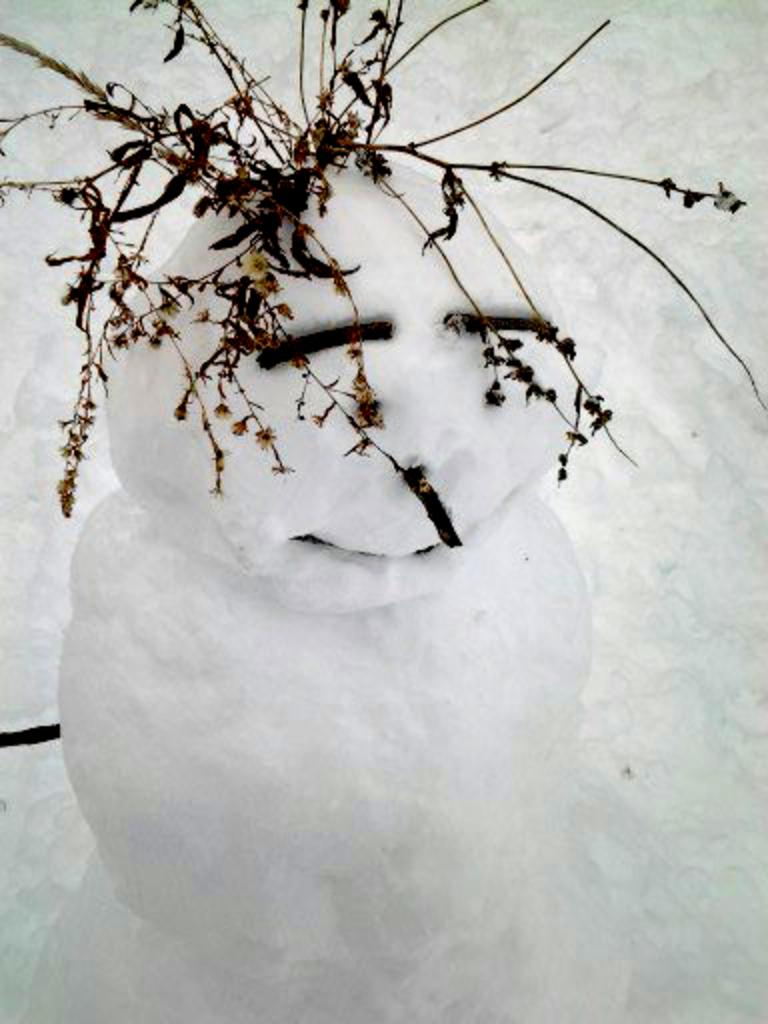What is the main subject of the picture? The main subject of the picture is a snowman. What is used to represent the snowman's arms in the image? Twigs are present at the top of the snowman. What type of weather is suggested by the background of the image? The presence of snow in the background suggests a cold, wintry environment. What type of mint plant can be seen growing near the snowman in the image? There is no mint plant present in the image; it features a snowman with twigs for arms and a snowy background. What type of creature is interacting with the snowman in the image? There is no creature interacting with the snowman in the image; it is a standalone snowman in a snowy environment. 